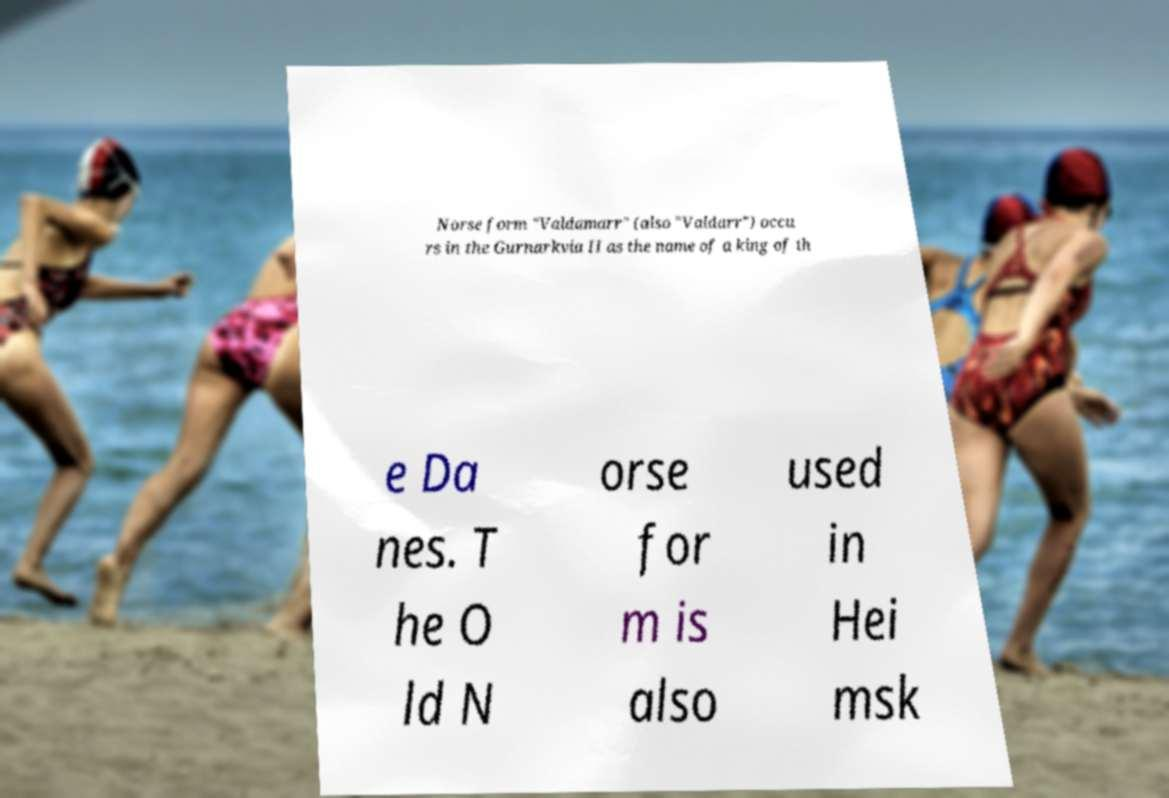I need the written content from this picture converted into text. Can you do that? Norse form "Valdamarr" (also "Valdarr") occu rs in the Gurnarkvia II as the name of a king of th e Da nes. T he O ld N orse for m is also used in Hei msk 